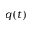<formula> <loc_0><loc_0><loc_500><loc_500>q ( t )</formula> 